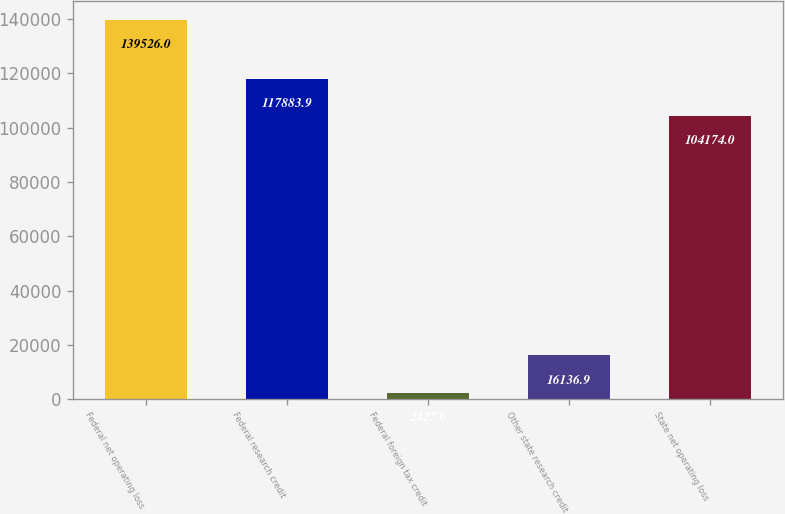Convert chart. <chart><loc_0><loc_0><loc_500><loc_500><bar_chart><fcel>Federal net operating loss<fcel>Federal research credit<fcel>Federal foreign tax credit<fcel>Other state research credit<fcel>State net operating loss<nl><fcel>139526<fcel>117884<fcel>2427<fcel>16136.9<fcel>104174<nl></chart> 